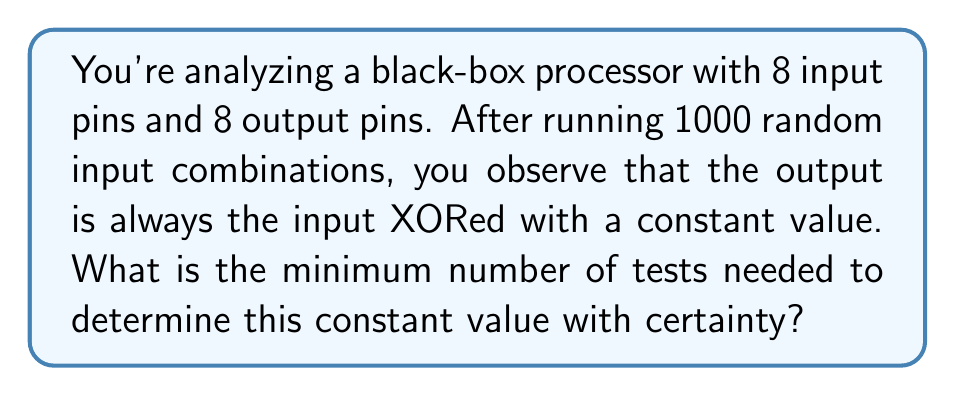Can you answer this question? Let's approach this step-by-step:

1) First, we need to understand what XOR operation does. For two binary digits $a$ and $b$:
   $a \oplus b = 0$ if $a = b$
   $a \oplus b = 1$ if $a \neq b$

2) Let's denote the constant value as $C = c_7c_6c_5c_4c_3c_2c_1c_0$, where each $c_i$ is a bit.

3) For any input $I = i_7i_6i_5i_4i_3i_2i_1i_0$, the output $O$ is:
   $O = I \oplus C = (i_7 \oplus c_7)(i_6 \oplus c_6)...(i_0 \oplus c_0)$

4) To determine each bit of $C$, we need to find a case where the corresponding input bit is 0:
   If $i_k = 0$, then $o_k = 0 \oplus c_k = c_k$

5) Therefore, we need at least one test case where each input bit is 0.

6) The input $00000000$ would reveal all bits of $C$ at once, as the output would be exactly $C$.

7) However, we're asked for the minimum number of tests. We don't need to test all 256 possibilities.

8) The minimum set of tests that ensures each input bit is 0 at least once is:
   $10000000$
   $01000000$
   $00100000$
   $00010000$
   $00001000$
   $00000100$
   $00000010$
   $00000001$

9) These 8 tests are sufficient and necessary to determine $C$ with certainty.
Answer: 8 tests 